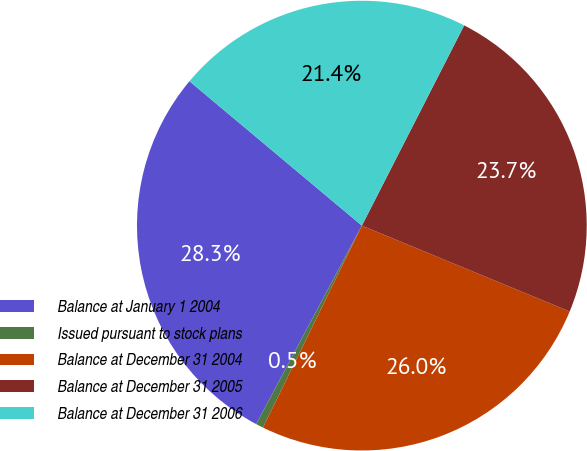<chart> <loc_0><loc_0><loc_500><loc_500><pie_chart><fcel>Balance at January 1 2004<fcel>Issued pursuant to stock plans<fcel>Balance at December 31 2004<fcel>Balance at December 31 2005<fcel>Balance at December 31 2006<nl><fcel>28.31%<fcel>0.54%<fcel>26.01%<fcel>23.72%<fcel>21.42%<nl></chart> 